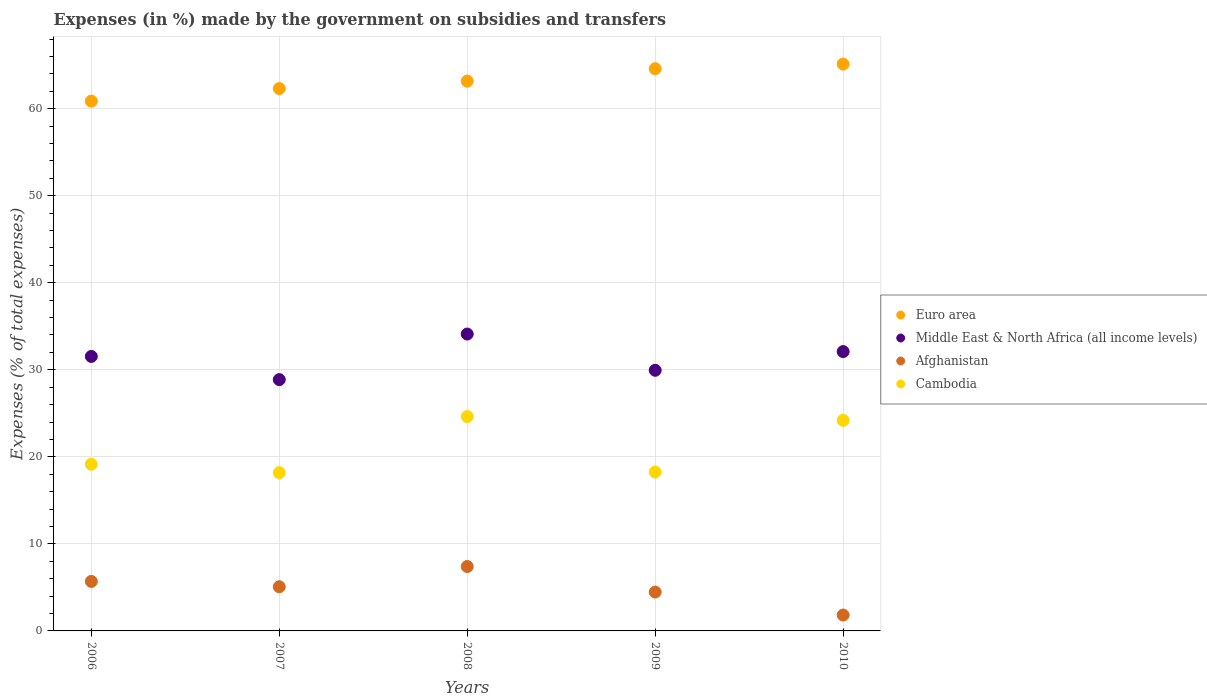How many different coloured dotlines are there?
Offer a terse response. 4. Is the number of dotlines equal to the number of legend labels?
Your answer should be very brief. Yes. What is the percentage of expenses made by the government on subsidies and transfers in Cambodia in 2007?
Offer a very short reply. 18.19. Across all years, what is the maximum percentage of expenses made by the government on subsidies and transfers in Cambodia?
Offer a terse response. 24.63. Across all years, what is the minimum percentage of expenses made by the government on subsidies and transfers in Euro area?
Offer a very short reply. 60.87. In which year was the percentage of expenses made by the government on subsidies and transfers in Euro area maximum?
Your response must be concise. 2010. What is the total percentage of expenses made by the government on subsidies and transfers in Middle East & North Africa (all income levels) in the graph?
Give a very brief answer. 156.55. What is the difference between the percentage of expenses made by the government on subsidies and transfers in Cambodia in 2007 and that in 2010?
Offer a very short reply. -6.01. What is the difference between the percentage of expenses made by the government on subsidies and transfers in Middle East & North Africa (all income levels) in 2006 and the percentage of expenses made by the government on subsidies and transfers in Afghanistan in 2007?
Offer a terse response. 26.46. What is the average percentage of expenses made by the government on subsidies and transfers in Cambodia per year?
Give a very brief answer. 20.88. In the year 2010, what is the difference between the percentage of expenses made by the government on subsidies and transfers in Cambodia and percentage of expenses made by the government on subsidies and transfers in Middle East & North Africa (all income levels)?
Your response must be concise. -7.9. In how many years, is the percentage of expenses made by the government on subsidies and transfers in Cambodia greater than 62 %?
Keep it short and to the point. 0. What is the ratio of the percentage of expenses made by the government on subsidies and transfers in Middle East & North Africa (all income levels) in 2006 to that in 2007?
Offer a terse response. 1.09. What is the difference between the highest and the second highest percentage of expenses made by the government on subsidies and transfers in Euro area?
Make the answer very short. 0.52. What is the difference between the highest and the lowest percentage of expenses made by the government on subsidies and transfers in Cambodia?
Your answer should be compact. 6.44. Is it the case that in every year, the sum of the percentage of expenses made by the government on subsidies and transfers in Middle East & North Africa (all income levels) and percentage of expenses made by the government on subsidies and transfers in Afghanistan  is greater than the sum of percentage of expenses made by the government on subsidies and transfers in Cambodia and percentage of expenses made by the government on subsidies and transfers in Euro area?
Your response must be concise. No. How many dotlines are there?
Offer a terse response. 4. How many years are there in the graph?
Give a very brief answer. 5. Does the graph contain grids?
Your response must be concise. Yes. How are the legend labels stacked?
Offer a terse response. Vertical. What is the title of the graph?
Your answer should be compact. Expenses (in %) made by the government on subsidies and transfers. What is the label or title of the X-axis?
Give a very brief answer. Years. What is the label or title of the Y-axis?
Give a very brief answer. Expenses (% of total expenses). What is the Expenses (% of total expenses) of Euro area in 2006?
Your response must be concise. 60.87. What is the Expenses (% of total expenses) of Middle East & North Africa (all income levels) in 2006?
Your response must be concise. 31.54. What is the Expenses (% of total expenses) of Afghanistan in 2006?
Offer a very short reply. 5.69. What is the Expenses (% of total expenses) in Cambodia in 2006?
Give a very brief answer. 19.15. What is the Expenses (% of total expenses) of Euro area in 2007?
Give a very brief answer. 62.31. What is the Expenses (% of total expenses) in Middle East & North Africa (all income levels) in 2007?
Offer a terse response. 28.87. What is the Expenses (% of total expenses) of Afghanistan in 2007?
Provide a short and direct response. 5.08. What is the Expenses (% of total expenses) of Cambodia in 2007?
Offer a terse response. 18.19. What is the Expenses (% of total expenses) in Euro area in 2008?
Your answer should be very brief. 63.17. What is the Expenses (% of total expenses) of Middle East & North Africa (all income levels) in 2008?
Make the answer very short. 34.11. What is the Expenses (% of total expenses) of Afghanistan in 2008?
Provide a succinct answer. 7.4. What is the Expenses (% of total expenses) of Cambodia in 2008?
Offer a very short reply. 24.63. What is the Expenses (% of total expenses) of Euro area in 2009?
Ensure brevity in your answer.  64.59. What is the Expenses (% of total expenses) in Middle East & North Africa (all income levels) in 2009?
Ensure brevity in your answer.  29.94. What is the Expenses (% of total expenses) of Afghanistan in 2009?
Your answer should be very brief. 4.47. What is the Expenses (% of total expenses) of Cambodia in 2009?
Provide a short and direct response. 18.25. What is the Expenses (% of total expenses) in Euro area in 2010?
Your response must be concise. 65.12. What is the Expenses (% of total expenses) of Middle East & North Africa (all income levels) in 2010?
Your answer should be compact. 32.09. What is the Expenses (% of total expenses) in Afghanistan in 2010?
Your response must be concise. 1.82. What is the Expenses (% of total expenses) of Cambodia in 2010?
Keep it short and to the point. 24.19. Across all years, what is the maximum Expenses (% of total expenses) of Euro area?
Offer a very short reply. 65.12. Across all years, what is the maximum Expenses (% of total expenses) in Middle East & North Africa (all income levels)?
Your response must be concise. 34.11. Across all years, what is the maximum Expenses (% of total expenses) in Afghanistan?
Keep it short and to the point. 7.4. Across all years, what is the maximum Expenses (% of total expenses) of Cambodia?
Make the answer very short. 24.63. Across all years, what is the minimum Expenses (% of total expenses) of Euro area?
Your answer should be very brief. 60.87. Across all years, what is the minimum Expenses (% of total expenses) of Middle East & North Africa (all income levels)?
Make the answer very short. 28.87. Across all years, what is the minimum Expenses (% of total expenses) of Afghanistan?
Keep it short and to the point. 1.82. Across all years, what is the minimum Expenses (% of total expenses) in Cambodia?
Your response must be concise. 18.19. What is the total Expenses (% of total expenses) of Euro area in the graph?
Keep it short and to the point. 316.06. What is the total Expenses (% of total expenses) in Middle East & North Africa (all income levels) in the graph?
Offer a very short reply. 156.55. What is the total Expenses (% of total expenses) of Afghanistan in the graph?
Your answer should be very brief. 24.45. What is the total Expenses (% of total expenses) in Cambodia in the graph?
Offer a terse response. 104.41. What is the difference between the Expenses (% of total expenses) in Euro area in 2006 and that in 2007?
Provide a succinct answer. -1.44. What is the difference between the Expenses (% of total expenses) in Middle East & North Africa (all income levels) in 2006 and that in 2007?
Your answer should be very brief. 2.67. What is the difference between the Expenses (% of total expenses) in Afghanistan in 2006 and that in 2007?
Ensure brevity in your answer.  0.61. What is the difference between the Expenses (% of total expenses) in Cambodia in 2006 and that in 2007?
Make the answer very short. 0.96. What is the difference between the Expenses (% of total expenses) in Euro area in 2006 and that in 2008?
Offer a very short reply. -2.3. What is the difference between the Expenses (% of total expenses) in Middle East & North Africa (all income levels) in 2006 and that in 2008?
Give a very brief answer. -2.57. What is the difference between the Expenses (% of total expenses) of Afghanistan in 2006 and that in 2008?
Give a very brief answer. -1.71. What is the difference between the Expenses (% of total expenses) of Cambodia in 2006 and that in 2008?
Your answer should be very brief. -5.48. What is the difference between the Expenses (% of total expenses) in Euro area in 2006 and that in 2009?
Offer a very short reply. -3.72. What is the difference between the Expenses (% of total expenses) of Middle East & North Africa (all income levels) in 2006 and that in 2009?
Give a very brief answer. 1.59. What is the difference between the Expenses (% of total expenses) in Afghanistan in 2006 and that in 2009?
Your answer should be very brief. 1.22. What is the difference between the Expenses (% of total expenses) in Cambodia in 2006 and that in 2009?
Ensure brevity in your answer.  0.9. What is the difference between the Expenses (% of total expenses) of Euro area in 2006 and that in 2010?
Your answer should be very brief. -4.25. What is the difference between the Expenses (% of total expenses) of Middle East & North Africa (all income levels) in 2006 and that in 2010?
Your response must be concise. -0.56. What is the difference between the Expenses (% of total expenses) of Afghanistan in 2006 and that in 2010?
Make the answer very short. 3.86. What is the difference between the Expenses (% of total expenses) in Cambodia in 2006 and that in 2010?
Your answer should be compact. -5.04. What is the difference between the Expenses (% of total expenses) in Euro area in 2007 and that in 2008?
Ensure brevity in your answer.  -0.86. What is the difference between the Expenses (% of total expenses) in Middle East & North Africa (all income levels) in 2007 and that in 2008?
Offer a very short reply. -5.24. What is the difference between the Expenses (% of total expenses) of Afghanistan in 2007 and that in 2008?
Make the answer very short. -2.32. What is the difference between the Expenses (% of total expenses) in Cambodia in 2007 and that in 2008?
Provide a succinct answer. -6.44. What is the difference between the Expenses (% of total expenses) in Euro area in 2007 and that in 2009?
Your response must be concise. -2.29. What is the difference between the Expenses (% of total expenses) of Middle East & North Africa (all income levels) in 2007 and that in 2009?
Offer a very short reply. -1.07. What is the difference between the Expenses (% of total expenses) of Afghanistan in 2007 and that in 2009?
Give a very brief answer. 0.61. What is the difference between the Expenses (% of total expenses) in Cambodia in 2007 and that in 2009?
Offer a very short reply. -0.06. What is the difference between the Expenses (% of total expenses) of Euro area in 2007 and that in 2010?
Your response must be concise. -2.81. What is the difference between the Expenses (% of total expenses) in Middle East & North Africa (all income levels) in 2007 and that in 2010?
Make the answer very short. -3.22. What is the difference between the Expenses (% of total expenses) in Afghanistan in 2007 and that in 2010?
Offer a very short reply. 3.25. What is the difference between the Expenses (% of total expenses) of Cambodia in 2007 and that in 2010?
Your response must be concise. -6.01. What is the difference between the Expenses (% of total expenses) in Euro area in 2008 and that in 2009?
Keep it short and to the point. -1.42. What is the difference between the Expenses (% of total expenses) in Middle East & North Africa (all income levels) in 2008 and that in 2009?
Offer a very short reply. 4.16. What is the difference between the Expenses (% of total expenses) in Afghanistan in 2008 and that in 2009?
Offer a very short reply. 2.93. What is the difference between the Expenses (% of total expenses) in Cambodia in 2008 and that in 2009?
Keep it short and to the point. 6.38. What is the difference between the Expenses (% of total expenses) in Euro area in 2008 and that in 2010?
Ensure brevity in your answer.  -1.95. What is the difference between the Expenses (% of total expenses) in Middle East & North Africa (all income levels) in 2008 and that in 2010?
Offer a very short reply. 2.02. What is the difference between the Expenses (% of total expenses) in Afghanistan in 2008 and that in 2010?
Keep it short and to the point. 5.57. What is the difference between the Expenses (% of total expenses) in Cambodia in 2008 and that in 2010?
Ensure brevity in your answer.  0.44. What is the difference between the Expenses (% of total expenses) in Euro area in 2009 and that in 2010?
Offer a terse response. -0.52. What is the difference between the Expenses (% of total expenses) in Middle East & North Africa (all income levels) in 2009 and that in 2010?
Keep it short and to the point. -2.15. What is the difference between the Expenses (% of total expenses) in Afghanistan in 2009 and that in 2010?
Provide a short and direct response. 2.64. What is the difference between the Expenses (% of total expenses) of Cambodia in 2009 and that in 2010?
Give a very brief answer. -5.94. What is the difference between the Expenses (% of total expenses) of Euro area in 2006 and the Expenses (% of total expenses) of Middle East & North Africa (all income levels) in 2007?
Keep it short and to the point. 32. What is the difference between the Expenses (% of total expenses) in Euro area in 2006 and the Expenses (% of total expenses) in Afghanistan in 2007?
Give a very brief answer. 55.79. What is the difference between the Expenses (% of total expenses) in Euro area in 2006 and the Expenses (% of total expenses) in Cambodia in 2007?
Provide a short and direct response. 42.68. What is the difference between the Expenses (% of total expenses) of Middle East & North Africa (all income levels) in 2006 and the Expenses (% of total expenses) of Afghanistan in 2007?
Your response must be concise. 26.46. What is the difference between the Expenses (% of total expenses) in Middle East & North Africa (all income levels) in 2006 and the Expenses (% of total expenses) in Cambodia in 2007?
Provide a short and direct response. 13.35. What is the difference between the Expenses (% of total expenses) of Afghanistan in 2006 and the Expenses (% of total expenses) of Cambodia in 2007?
Your answer should be very brief. -12.5. What is the difference between the Expenses (% of total expenses) in Euro area in 2006 and the Expenses (% of total expenses) in Middle East & North Africa (all income levels) in 2008?
Your response must be concise. 26.76. What is the difference between the Expenses (% of total expenses) of Euro area in 2006 and the Expenses (% of total expenses) of Afghanistan in 2008?
Offer a very short reply. 53.47. What is the difference between the Expenses (% of total expenses) of Euro area in 2006 and the Expenses (% of total expenses) of Cambodia in 2008?
Provide a succinct answer. 36.24. What is the difference between the Expenses (% of total expenses) of Middle East & North Africa (all income levels) in 2006 and the Expenses (% of total expenses) of Afghanistan in 2008?
Your response must be concise. 24.14. What is the difference between the Expenses (% of total expenses) in Middle East & North Africa (all income levels) in 2006 and the Expenses (% of total expenses) in Cambodia in 2008?
Offer a very short reply. 6.91. What is the difference between the Expenses (% of total expenses) in Afghanistan in 2006 and the Expenses (% of total expenses) in Cambodia in 2008?
Give a very brief answer. -18.94. What is the difference between the Expenses (% of total expenses) in Euro area in 2006 and the Expenses (% of total expenses) in Middle East & North Africa (all income levels) in 2009?
Your answer should be compact. 30.93. What is the difference between the Expenses (% of total expenses) in Euro area in 2006 and the Expenses (% of total expenses) in Afghanistan in 2009?
Offer a terse response. 56.4. What is the difference between the Expenses (% of total expenses) of Euro area in 2006 and the Expenses (% of total expenses) of Cambodia in 2009?
Your answer should be very brief. 42.62. What is the difference between the Expenses (% of total expenses) in Middle East & North Africa (all income levels) in 2006 and the Expenses (% of total expenses) in Afghanistan in 2009?
Offer a terse response. 27.07. What is the difference between the Expenses (% of total expenses) in Middle East & North Africa (all income levels) in 2006 and the Expenses (% of total expenses) in Cambodia in 2009?
Provide a succinct answer. 13.29. What is the difference between the Expenses (% of total expenses) in Afghanistan in 2006 and the Expenses (% of total expenses) in Cambodia in 2009?
Provide a succinct answer. -12.56. What is the difference between the Expenses (% of total expenses) of Euro area in 2006 and the Expenses (% of total expenses) of Middle East & North Africa (all income levels) in 2010?
Ensure brevity in your answer.  28.78. What is the difference between the Expenses (% of total expenses) in Euro area in 2006 and the Expenses (% of total expenses) in Afghanistan in 2010?
Offer a very short reply. 59.04. What is the difference between the Expenses (% of total expenses) in Euro area in 2006 and the Expenses (% of total expenses) in Cambodia in 2010?
Your answer should be very brief. 36.68. What is the difference between the Expenses (% of total expenses) in Middle East & North Africa (all income levels) in 2006 and the Expenses (% of total expenses) in Afghanistan in 2010?
Provide a short and direct response. 29.71. What is the difference between the Expenses (% of total expenses) of Middle East & North Africa (all income levels) in 2006 and the Expenses (% of total expenses) of Cambodia in 2010?
Offer a very short reply. 7.34. What is the difference between the Expenses (% of total expenses) in Afghanistan in 2006 and the Expenses (% of total expenses) in Cambodia in 2010?
Make the answer very short. -18.51. What is the difference between the Expenses (% of total expenses) of Euro area in 2007 and the Expenses (% of total expenses) of Middle East & North Africa (all income levels) in 2008?
Ensure brevity in your answer.  28.2. What is the difference between the Expenses (% of total expenses) of Euro area in 2007 and the Expenses (% of total expenses) of Afghanistan in 2008?
Your answer should be compact. 54.91. What is the difference between the Expenses (% of total expenses) in Euro area in 2007 and the Expenses (% of total expenses) in Cambodia in 2008?
Your answer should be compact. 37.68. What is the difference between the Expenses (% of total expenses) of Middle East & North Africa (all income levels) in 2007 and the Expenses (% of total expenses) of Afghanistan in 2008?
Your answer should be compact. 21.47. What is the difference between the Expenses (% of total expenses) of Middle East & North Africa (all income levels) in 2007 and the Expenses (% of total expenses) of Cambodia in 2008?
Ensure brevity in your answer.  4.24. What is the difference between the Expenses (% of total expenses) of Afghanistan in 2007 and the Expenses (% of total expenses) of Cambodia in 2008?
Ensure brevity in your answer.  -19.55. What is the difference between the Expenses (% of total expenses) in Euro area in 2007 and the Expenses (% of total expenses) in Middle East & North Africa (all income levels) in 2009?
Keep it short and to the point. 32.36. What is the difference between the Expenses (% of total expenses) of Euro area in 2007 and the Expenses (% of total expenses) of Afghanistan in 2009?
Your response must be concise. 57.84. What is the difference between the Expenses (% of total expenses) of Euro area in 2007 and the Expenses (% of total expenses) of Cambodia in 2009?
Make the answer very short. 44.06. What is the difference between the Expenses (% of total expenses) in Middle East & North Africa (all income levels) in 2007 and the Expenses (% of total expenses) in Afghanistan in 2009?
Ensure brevity in your answer.  24.4. What is the difference between the Expenses (% of total expenses) of Middle East & North Africa (all income levels) in 2007 and the Expenses (% of total expenses) of Cambodia in 2009?
Your answer should be compact. 10.62. What is the difference between the Expenses (% of total expenses) of Afghanistan in 2007 and the Expenses (% of total expenses) of Cambodia in 2009?
Offer a terse response. -13.18. What is the difference between the Expenses (% of total expenses) of Euro area in 2007 and the Expenses (% of total expenses) of Middle East & North Africa (all income levels) in 2010?
Your answer should be very brief. 30.22. What is the difference between the Expenses (% of total expenses) in Euro area in 2007 and the Expenses (% of total expenses) in Afghanistan in 2010?
Offer a very short reply. 60.48. What is the difference between the Expenses (% of total expenses) of Euro area in 2007 and the Expenses (% of total expenses) of Cambodia in 2010?
Your answer should be compact. 38.12. What is the difference between the Expenses (% of total expenses) in Middle East & North Africa (all income levels) in 2007 and the Expenses (% of total expenses) in Afghanistan in 2010?
Your answer should be very brief. 27.05. What is the difference between the Expenses (% of total expenses) of Middle East & North Africa (all income levels) in 2007 and the Expenses (% of total expenses) of Cambodia in 2010?
Your response must be concise. 4.68. What is the difference between the Expenses (% of total expenses) of Afghanistan in 2007 and the Expenses (% of total expenses) of Cambodia in 2010?
Your response must be concise. -19.12. What is the difference between the Expenses (% of total expenses) in Euro area in 2008 and the Expenses (% of total expenses) in Middle East & North Africa (all income levels) in 2009?
Offer a terse response. 33.23. What is the difference between the Expenses (% of total expenses) of Euro area in 2008 and the Expenses (% of total expenses) of Afghanistan in 2009?
Give a very brief answer. 58.7. What is the difference between the Expenses (% of total expenses) of Euro area in 2008 and the Expenses (% of total expenses) of Cambodia in 2009?
Make the answer very short. 44.92. What is the difference between the Expenses (% of total expenses) of Middle East & North Africa (all income levels) in 2008 and the Expenses (% of total expenses) of Afghanistan in 2009?
Provide a short and direct response. 29.64. What is the difference between the Expenses (% of total expenses) of Middle East & North Africa (all income levels) in 2008 and the Expenses (% of total expenses) of Cambodia in 2009?
Make the answer very short. 15.86. What is the difference between the Expenses (% of total expenses) of Afghanistan in 2008 and the Expenses (% of total expenses) of Cambodia in 2009?
Your response must be concise. -10.85. What is the difference between the Expenses (% of total expenses) of Euro area in 2008 and the Expenses (% of total expenses) of Middle East & North Africa (all income levels) in 2010?
Make the answer very short. 31.08. What is the difference between the Expenses (% of total expenses) of Euro area in 2008 and the Expenses (% of total expenses) of Afghanistan in 2010?
Provide a succinct answer. 61.34. What is the difference between the Expenses (% of total expenses) of Euro area in 2008 and the Expenses (% of total expenses) of Cambodia in 2010?
Keep it short and to the point. 38.98. What is the difference between the Expenses (% of total expenses) of Middle East & North Africa (all income levels) in 2008 and the Expenses (% of total expenses) of Afghanistan in 2010?
Provide a short and direct response. 32.28. What is the difference between the Expenses (% of total expenses) of Middle East & North Africa (all income levels) in 2008 and the Expenses (% of total expenses) of Cambodia in 2010?
Ensure brevity in your answer.  9.91. What is the difference between the Expenses (% of total expenses) in Afghanistan in 2008 and the Expenses (% of total expenses) in Cambodia in 2010?
Provide a succinct answer. -16.79. What is the difference between the Expenses (% of total expenses) in Euro area in 2009 and the Expenses (% of total expenses) in Middle East & North Africa (all income levels) in 2010?
Your response must be concise. 32.5. What is the difference between the Expenses (% of total expenses) of Euro area in 2009 and the Expenses (% of total expenses) of Afghanistan in 2010?
Your answer should be very brief. 62.77. What is the difference between the Expenses (% of total expenses) of Euro area in 2009 and the Expenses (% of total expenses) of Cambodia in 2010?
Provide a short and direct response. 40.4. What is the difference between the Expenses (% of total expenses) of Middle East & North Africa (all income levels) in 2009 and the Expenses (% of total expenses) of Afghanistan in 2010?
Keep it short and to the point. 28.12. What is the difference between the Expenses (% of total expenses) in Middle East & North Africa (all income levels) in 2009 and the Expenses (% of total expenses) in Cambodia in 2010?
Offer a terse response. 5.75. What is the difference between the Expenses (% of total expenses) of Afghanistan in 2009 and the Expenses (% of total expenses) of Cambodia in 2010?
Give a very brief answer. -19.73. What is the average Expenses (% of total expenses) of Euro area per year?
Give a very brief answer. 63.21. What is the average Expenses (% of total expenses) of Middle East & North Africa (all income levels) per year?
Provide a short and direct response. 31.31. What is the average Expenses (% of total expenses) in Afghanistan per year?
Give a very brief answer. 4.89. What is the average Expenses (% of total expenses) of Cambodia per year?
Offer a very short reply. 20.88. In the year 2006, what is the difference between the Expenses (% of total expenses) in Euro area and Expenses (% of total expenses) in Middle East & North Africa (all income levels)?
Give a very brief answer. 29.33. In the year 2006, what is the difference between the Expenses (% of total expenses) of Euro area and Expenses (% of total expenses) of Afghanistan?
Keep it short and to the point. 55.18. In the year 2006, what is the difference between the Expenses (% of total expenses) of Euro area and Expenses (% of total expenses) of Cambodia?
Ensure brevity in your answer.  41.72. In the year 2006, what is the difference between the Expenses (% of total expenses) of Middle East & North Africa (all income levels) and Expenses (% of total expenses) of Afghanistan?
Ensure brevity in your answer.  25.85. In the year 2006, what is the difference between the Expenses (% of total expenses) of Middle East & North Africa (all income levels) and Expenses (% of total expenses) of Cambodia?
Ensure brevity in your answer.  12.39. In the year 2006, what is the difference between the Expenses (% of total expenses) of Afghanistan and Expenses (% of total expenses) of Cambodia?
Ensure brevity in your answer.  -13.46. In the year 2007, what is the difference between the Expenses (% of total expenses) of Euro area and Expenses (% of total expenses) of Middle East & North Africa (all income levels)?
Keep it short and to the point. 33.44. In the year 2007, what is the difference between the Expenses (% of total expenses) of Euro area and Expenses (% of total expenses) of Afghanistan?
Your response must be concise. 57.23. In the year 2007, what is the difference between the Expenses (% of total expenses) of Euro area and Expenses (% of total expenses) of Cambodia?
Your answer should be very brief. 44.12. In the year 2007, what is the difference between the Expenses (% of total expenses) of Middle East & North Africa (all income levels) and Expenses (% of total expenses) of Afghanistan?
Offer a terse response. 23.8. In the year 2007, what is the difference between the Expenses (% of total expenses) in Middle East & North Africa (all income levels) and Expenses (% of total expenses) in Cambodia?
Your response must be concise. 10.68. In the year 2007, what is the difference between the Expenses (% of total expenses) in Afghanistan and Expenses (% of total expenses) in Cambodia?
Offer a terse response. -13.11. In the year 2008, what is the difference between the Expenses (% of total expenses) in Euro area and Expenses (% of total expenses) in Middle East & North Africa (all income levels)?
Offer a very short reply. 29.06. In the year 2008, what is the difference between the Expenses (% of total expenses) in Euro area and Expenses (% of total expenses) in Afghanistan?
Provide a succinct answer. 55.77. In the year 2008, what is the difference between the Expenses (% of total expenses) of Euro area and Expenses (% of total expenses) of Cambodia?
Offer a terse response. 38.54. In the year 2008, what is the difference between the Expenses (% of total expenses) in Middle East & North Africa (all income levels) and Expenses (% of total expenses) in Afghanistan?
Offer a terse response. 26.71. In the year 2008, what is the difference between the Expenses (% of total expenses) of Middle East & North Africa (all income levels) and Expenses (% of total expenses) of Cambodia?
Your response must be concise. 9.48. In the year 2008, what is the difference between the Expenses (% of total expenses) of Afghanistan and Expenses (% of total expenses) of Cambodia?
Ensure brevity in your answer.  -17.23. In the year 2009, what is the difference between the Expenses (% of total expenses) in Euro area and Expenses (% of total expenses) in Middle East & North Africa (all income levels)?
Your answer should be very brief. 34.65. In the year 2009, what is the difference between the Expenses (% of total expenses) of Euro area and Expenses (% of total expenses) of Afghanistan?
Your answer should be very brief. 60.13. In the year 2009, what is the difference between the Expenses (% of total expenses) in Euro area and Expenses (% of total expenses) in Cambodia?
Your answer should be very brief. 46.34. In the year 2009, what is the difference between the Expenses (% of total expenses) of Middle East & North Africa (all income levels) and Expenses (% of total expenses) of Afghanistan?
Your response must be concise. 25.48. In the year 2009, what is the difference between the Expenses (% of total expenses) in Middle East & North Africa (all income levels) and Expenses (% of total expenses) in Cambodia?
Your answer should be very brief. 11.69. In the year 2009, what is the difference between the Expenses (% of total expenses) in Afghanistan and Expenses (% of total expenses) in Cambodia?
Ensure brevity in your answer.  -13.78. In the year 2010, what is the difference between the Expenses (% of total expenses) in Euro area and Expenses (% of total expenses) in Middle East & North Africa (all income levels)?
Provide a succinct answer. 33.03. In the year 2010, what is the difference between the Expenses (% of total expenses) of Euro area and Expenses (% of total expenses) of Afghanistan?
Ensure brevity in your answer.  63.29. In the year 2010, what is the difference between the Expenses (% of total expenses) in Euro area and Expenses (% of total expenses) in Cambodia?
Provide a succinct answer. 40.93. In the year 2010, what is the difference between the Expenses (% of total expenses) in Middle East & North Africa (all income levels) and Expenses (% of total expenses) in Afghanistan?
Offer a very short reply. 30.27. In the year 2010, what is the difference between the Expenses (% of total expenses) in Middle East & North Africa (all income levels) and Expenses (% of total expenses) in Cambodia?
Your answer should be very brief. 7.9. In the year 2010, what is the difference between the Expenses (% of total expenses) in Afghanistan and Expenses (% of total expenses) in Cambodia?
Provide a short and direct response. -22.37. What is the ratio of the Expenses (% of total expenses) of Euro area in 2006 to that in 2007?
Make the answer very short. 0.98. What is the ratio of the Expenses (% of total expenses) of Middle East & North Africa (all income levels) in 2006 to that in 2007?
Provide a succinct answer. 1.09. What is the ratio of the Expenses (% of total expenses) in Afghanistan in 2006 to that in 2007?
Make the answer very short. 1.12. What is the ratio of the Expenses (% of total expenses) in Cambodia in 2006 to that in 2007?
Your response must be concise. 1.05. What is the ratio of the Expenses (% of total expenses) of Euro area in 2006 to that in 2008?
Offer a terse response. 0.96. What is the ratio of the Expenses (% of total expenses) in Middle East & North Africa (all income levels) in 2006 to that in 2008?
Give a very brief answer. 0.92. What is the ratio of the Expenses (% of total expenses) of Afghanistan in 2006 to that in 2008?
Your answer should be compact. 0.77. What is the ratio of the Expenses (% of total expenses) of Cambodia in 2006 to that in 2008?
Provide a short and direct response. 0.78. What is the ratio of the Expenses (% of total expenses) in Euro area in 2006 to that in 2009?
Give a very brief answer. 0.94. What is the ratio of the Expenses (% of total expenses) in Middle East & North Africa (all income levels) in 2006 to that in 2009?
Offer a very short reply. 1.05. What is the ratio of the Expenses (% of total expenses) of Afghanistan in 2006 to that in 2009?
Provide a succinct answer. 1.27. What is the ratio of the Expenses (% of total expenses) in Cambodia in 2006 to that in 2009?
Provide a succinct answer. 1.05. What is the ratio of the Expenses (% of total expenses) in Euro area in 2006 to that in 2010?
Provide a succinct answer. 0.93. What is the ratio of the Expenses (% of total expenses) of Middle East & North Africa (all income levels) in 2006 to that in 2010?
Your answer should be compact. 0.98. What is the ratio of the Expenses (% of total expenses) of Afghanistan in 2006 to that in 2010?
Your answer should be very brief. 3.12. What is the ratio of the Expenses (% of total expenses) of Cambodia in 2006 to that in 2010?
Provide a short and direct response. 0.79. What is the ratio of the Expenses (% of total expenses) in Euro area in 2007 to that in 2008?
Offer a terse response. 0.99. What is the ratio of the Expenses (% of total expenses) of Middle East & North Africa (all income levels) in 2007 to that in 2008?
Your answer should be compact. 0.85. What is the ratio of the Expenses (% of total expenses) of Afghanistan in 2007 to that in 2008?
Keep it short and to the point. 0.69. What is the ratio of the Expenses (% of total expenses) in Cambodia in 2007 to that in 2008?
Offer a very short reply. 0.74. What is the ratio of the Expenses (% of total expenses) in Euro area in 2007 to that in 2009?
Ensure brevity in your answer.  0.96. What is the ratio of the Expenses (% of total expenses) in Middle East & North Africa (all income levels) in 2007 to that in 2009?
Offer a very short reply. 0.96. What is the ratio of the Expenses (% of total expenses) in Afghanistan in 2007 to that in 2009?
Offer a very short reply. 1.14. What is the ratio of the Expenses (% of total expenses) of Cambodia in 2007 to that in 2009?
Offer a terse response. 1. What is the ratio of the Expenses (% of total expenses) in Euro area in 2007 to that in 2010?
Offer a very short reply. 0.96. What is the ratio of the Expenses (% of total expenses) of Middle East & North Africa (all income levels) in 2007 to that in 2010?
Provide a succinct answer. 0.9. What is the ratio of the Expenses (% of total expenses) of Afghanistan in 2007 to that in 2010?
Provide a short and direct response. 2.78. What is the ratio of the Expenses (% of total expenses) of Cambodia in 2007 to that in 2010?
Your answer should be very brief. 0.75. What is the ratio of the Expenses (% of total expenses) of Euro area in 2008 to that in 2009?
Ensure brevity in your answer.  0.98. What is the ratio of the Expenses (% of total expenses) in Middle East & North Africa (all income levels) in 2008 to that in 2009?
Keep it short and to the point. 1.14. What is the ratio of the Expenses (% of total expenses) of Afghanistan in 2008 to that in 2009?
Offer a terse response. 1.66. What is the ratio of the Expenses (% of total expenses) in Cambodia in 2008 to that in 2009?
Keep it short and to the point. 1.35. What is the ratio of the Expenses (% of total expenses) of Euro area in 2008 to that in 2010?
Provide a short and direct response. 0.97. What is the ratio of the Expenses (% of total expenses) of Middle East & North Africa (all income levels) in 2008 to that in 2010?
Make the answer very short. 1.06. What is the ratio of the Expenses (% of total expenses) of Afghanistan in 2008 to that in 2010?
Your answer should be compact. 4.05. What is the ratio of the Expenses (% of total expenses) in Cambodia in 2008 to that in 2010?
Provide a succinct answer. 1.02. What is the ratio of the Expenses (% of total expenses) in Middle East & North Africa (all income levels) in 2009 to that in 2010?
Offer a very short reply. 0.93. What is the ratio of the Expenses (% of total expenses) of Afghanistan in 2009 to that in 2010?
Make the answer very short. 2.45. What is the ratio of the Expenses (% of total expenses) of Cambodia in 2009 to that in 2010?
Ensure brevity in your answer.  0.75. What is the difference between the highest and the second highest Expenses (% of total expenses) of Euro area?
Your answer should be compact. 0.52. What is the difference between the highest and the second highest Expenses (% of total expenses) in Middle East & North Africa (all income levels)?
Give a very brief answer. 2.02. What is the difference between the highest and the second highest Expenses (% of total expenses) in Afghanistan?
Provide a short and direct response. 1.71. What is the difference between the highest and the second highest Expenses (% of total expenses) of Cambodia?
Make the answer very short. 0.44. What is the difference between the highest and the lowest Expenses (% of total expenses) in Euro area?
Provide a succinct answer. 4.25. What is the difference between the highest and the lowest Expenses (% of total expenses) in Middle East & North Africa (all income levels)?
Keep it short and to the point. 5.24. What is the difference between the highest and the lowest Expenses (% of total expenses) of Afghanistan?
Ensure brevity in your answer.  5.57. What is the difference between the highest and the lowest Expenses (% of total expenses) of Cambodia?
Give a very brief answer. 6.44. 